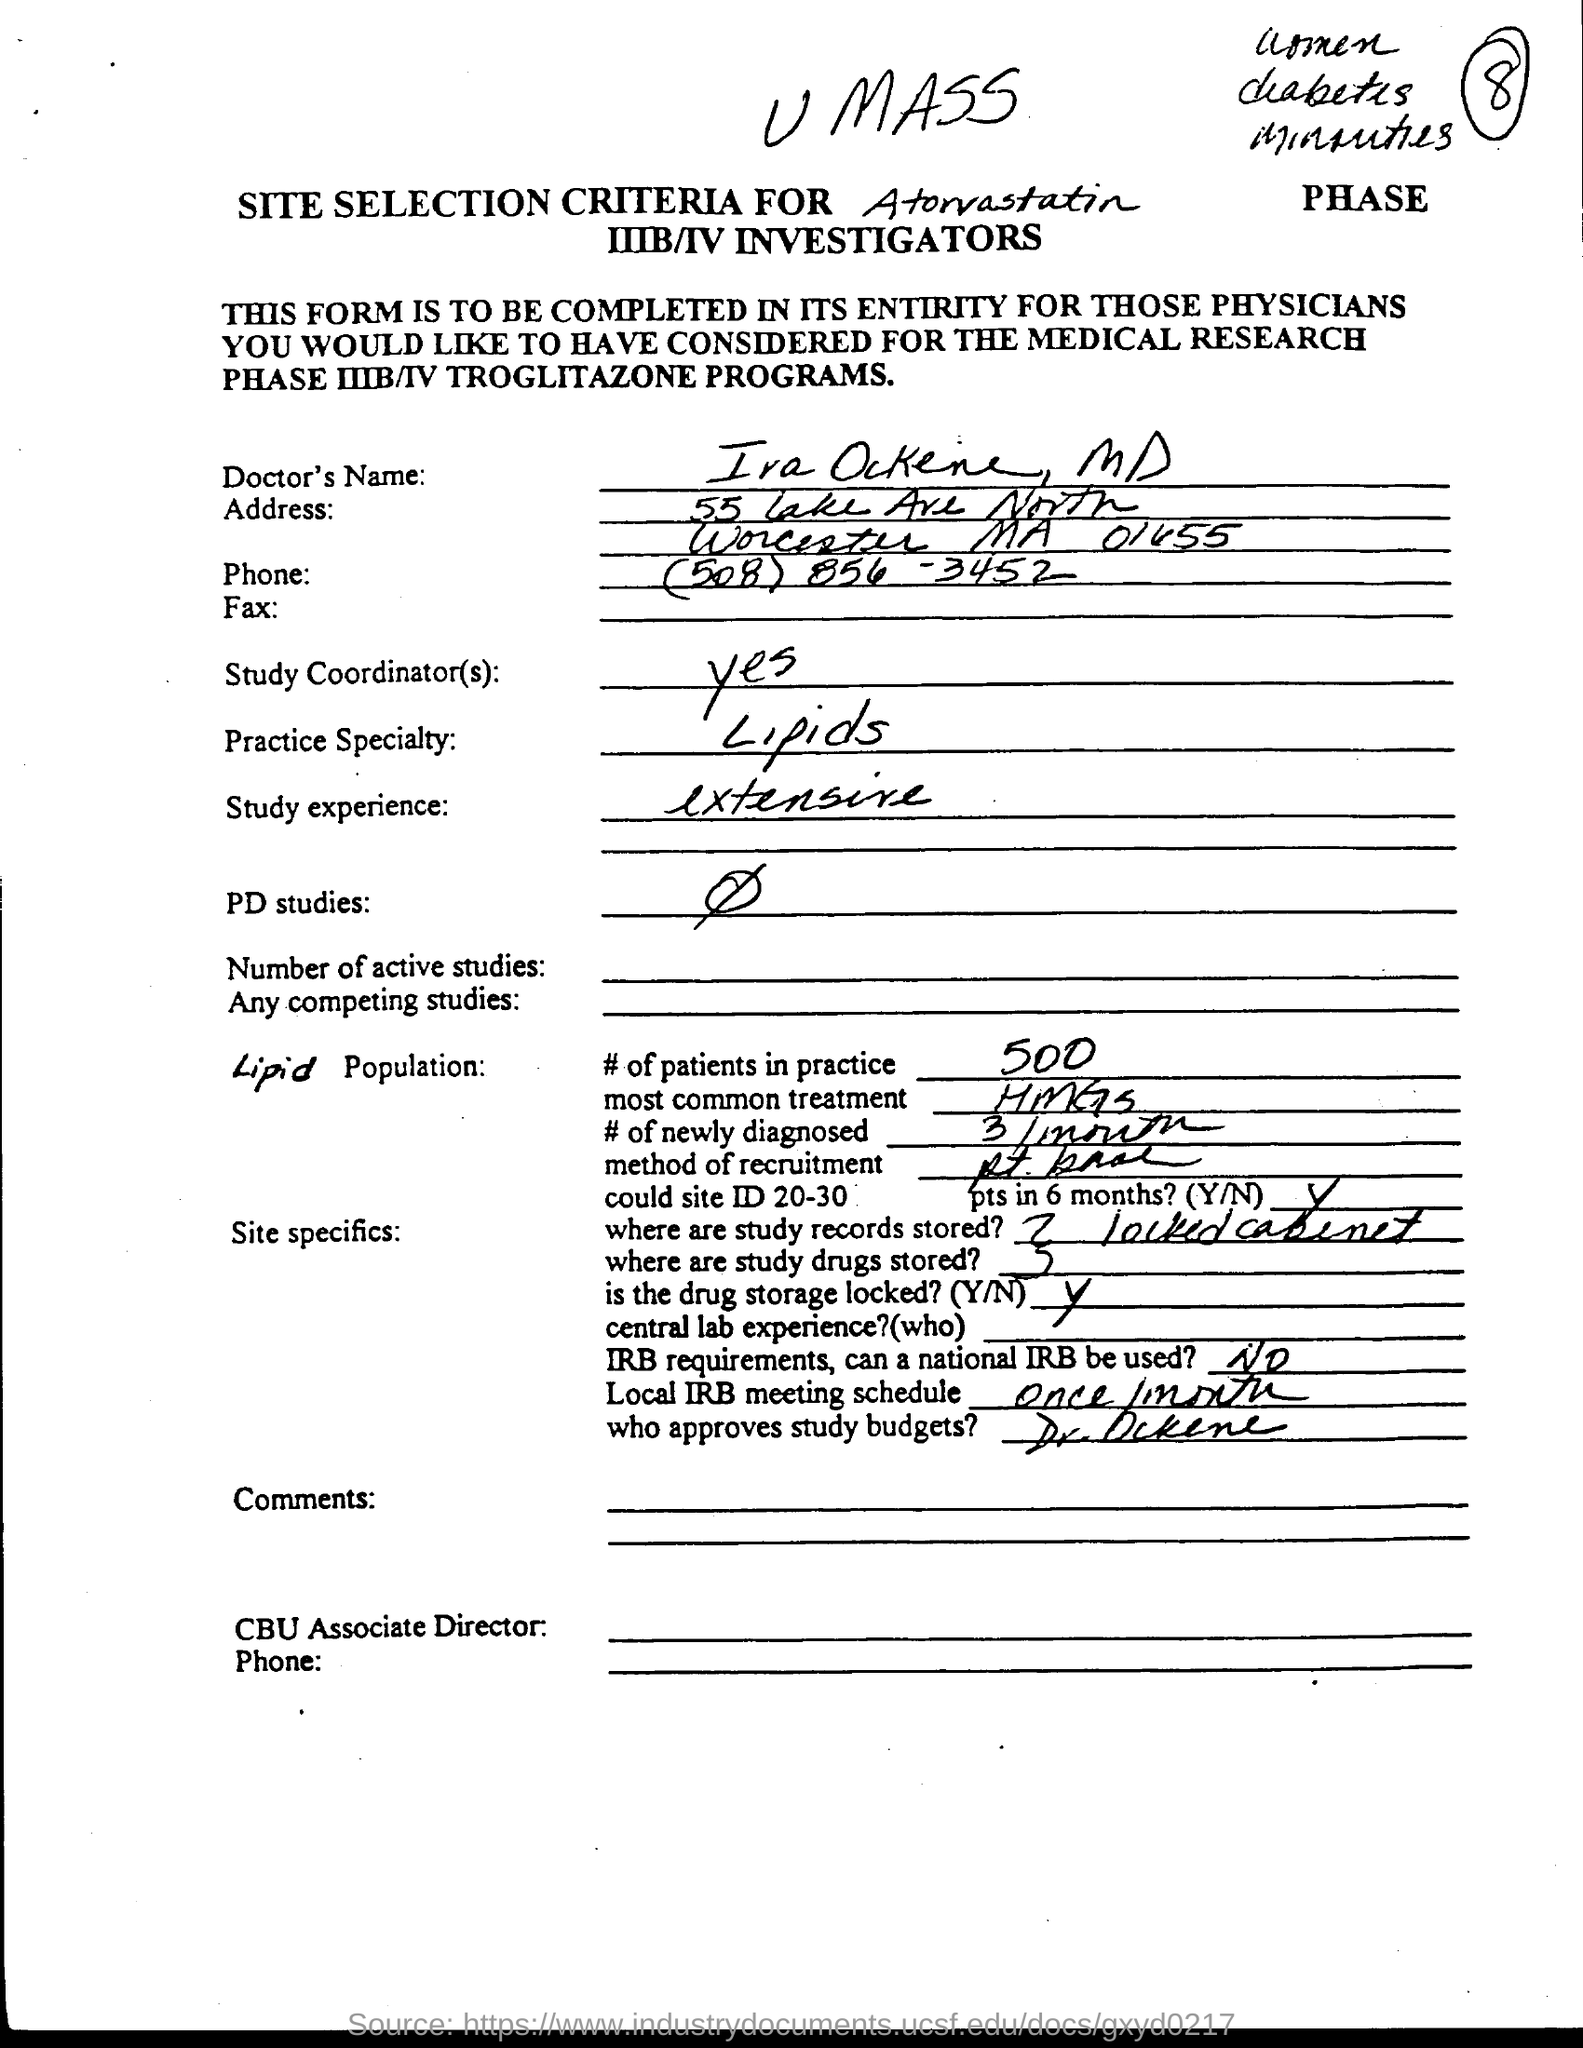What is the Doctor's Name?
Offer a terse response. Ira Ockene. What is the Doctor's Practice Specialty?
Offer a very short reply. Lipids. What is the Study experience?
Your answer should be compact. Extensive. Is the drug storage locked?(Y/N)
Give a very brief answer. Y. 